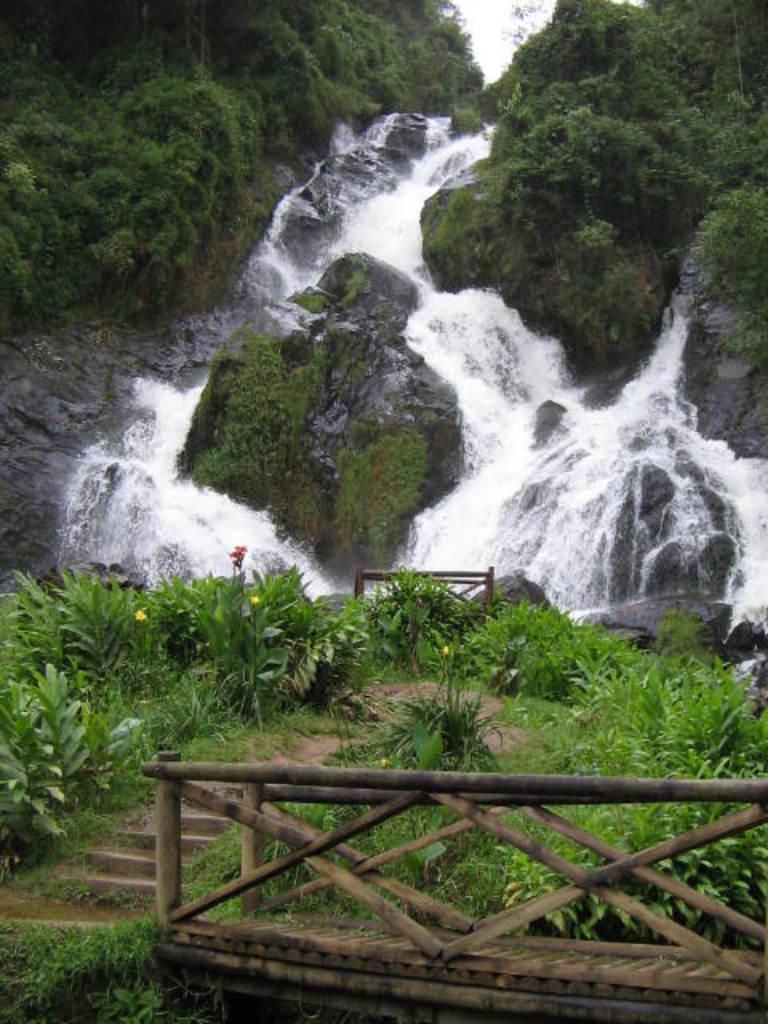How would you summarize this image in a sentence or two? In this image we can see wooden fence, steps, plants waterfall, rocks and trees in the background. 